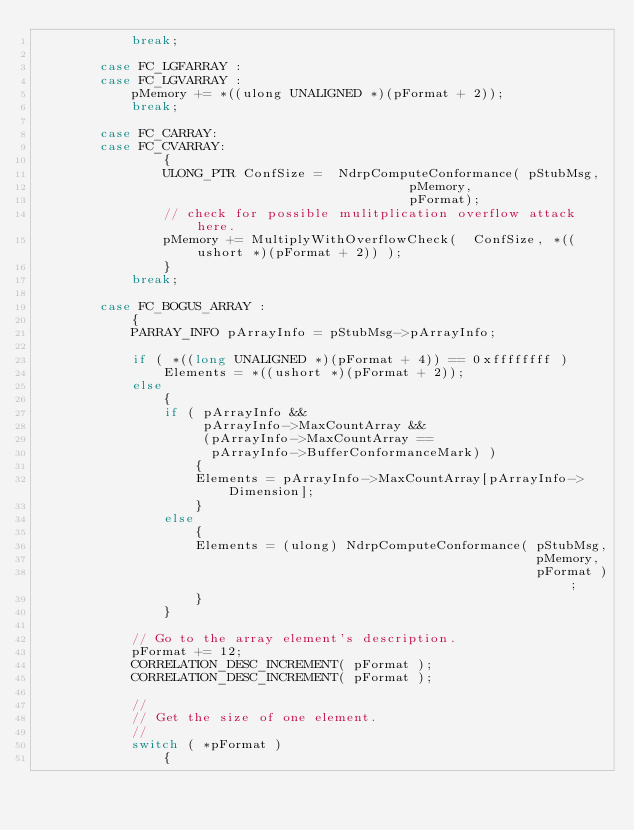Convert code to text. <code><loc_0><loc_0><loc_500><loc_500><_C++_>            break;

        case FC_LGFARRAY :
        case FC_LGVARRAY :
            pMemory += *((ulong UNALIGNED *)(pFormat + 2));
            break;

        case FC_CARRAY:
        case FC_CVARRAY:
                {
                ULONG_PTR ConfSize =  NdrpComputeConformance( pStubMsg, 
                                               pMemory, 
                                               pFormat);
                // check for possible mulitplication overflow attack here.
                pMemory += MultiplyWithOverflowCheck(  ConfSize, *((ushort *)(pFormat + 2)) );
                }
            break;

        case FC_BOGUS_ARRAY :
            {
            PARRAY_INFO pArrayInfo = pStubMsg->pArrayInfo;

            if ( *((long UNALIGNED *)(pFormat + 4)) == 0xffffffff )
                Elements = *((ushort *)(pFormat + 2));
            else
                {
                if ( pArrayInfo && 
                     pArrayInfo->MaxCountArray &&
                     (pArrayInfo->MaxCountArray ==  
                      pArrayInfo->BufferConformanceMark) )
                    {
                    Elements = pArrayInfo->MaxCountArray[pArrayInfo->Dimension];
                    }
                else
                    {
                    Elements = (ulong) NdrpComputeConformance( pStubMsg,
                                                               pMemory,
                                                               pFormat );
                    }
                }

            // Go to the array element's description.
            pFormat += 12;
            CORRELATION_DESC_INCREMENT( pFormat );
            CORRELATION_DESC_INCREMENT( pFormat );

            // 
            // Get the size of one element.
            //
            switch ( *pFormat )
                {</code> 